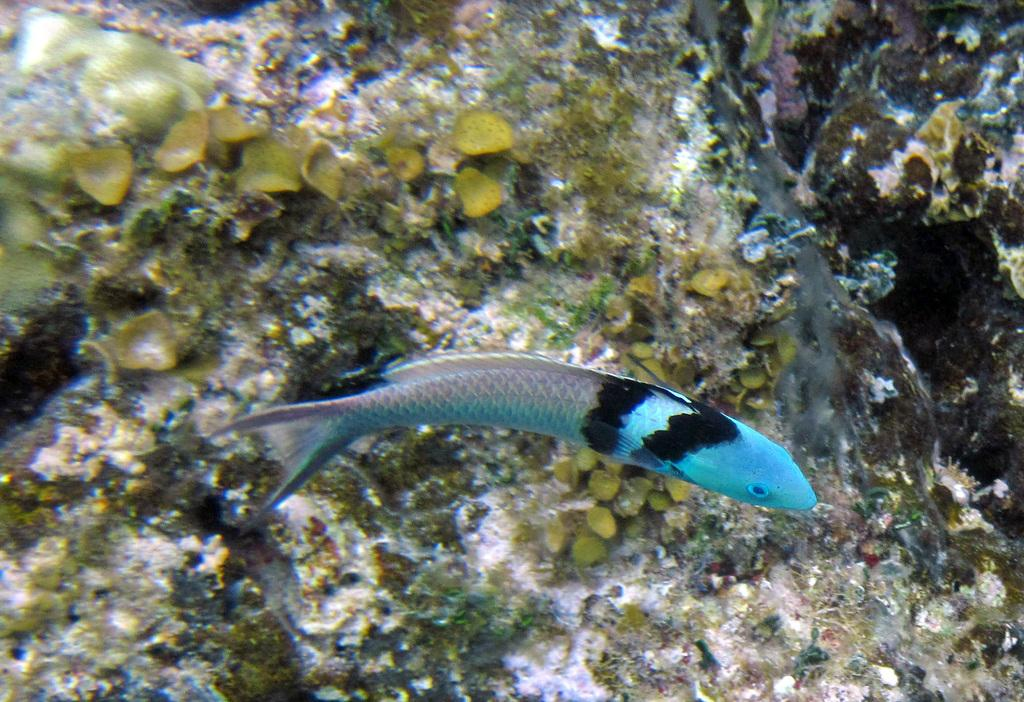What type of animal is in the image? There is a blue and black fish in the image. Where is the fish located in the image? The fish is in the front of the image. What can be seen in the background of the image? There is sea fungus visible in the background of the image. How does the fish change its color in the image? The fish does not change its color in the image; it remains blue and black. Can you tell me how the fish swims in the image? The image is a still image, so we cannot see the fish swimming. 